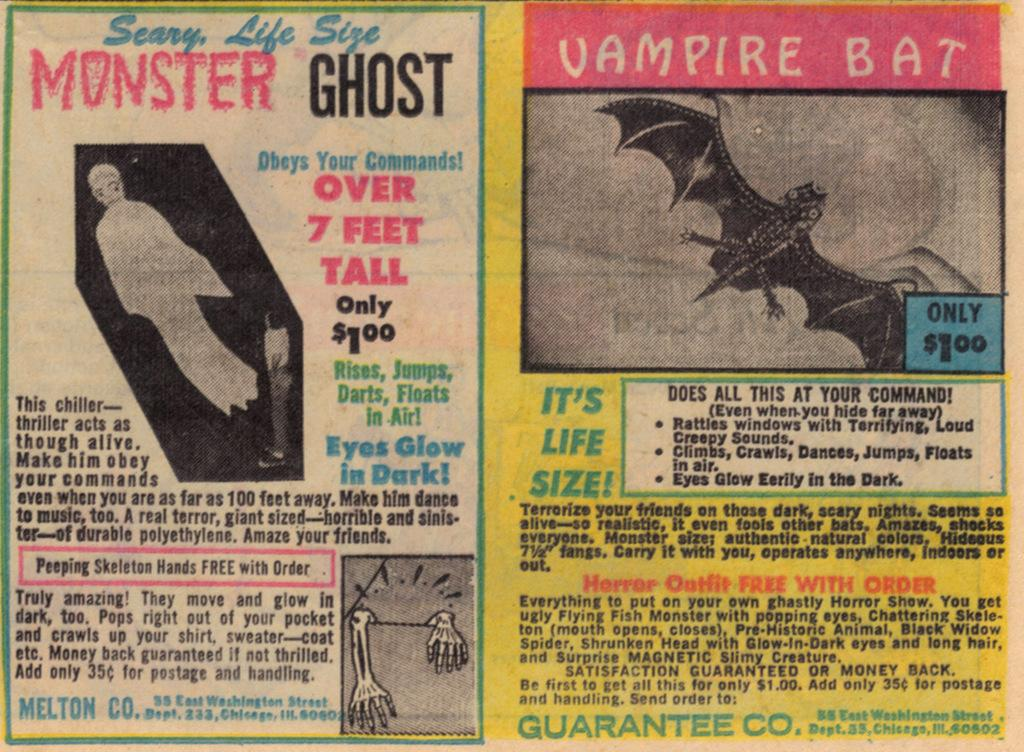<image>
Summarize the visual content of the image. Tabloid type magazine pages with a vampire bat on it. 